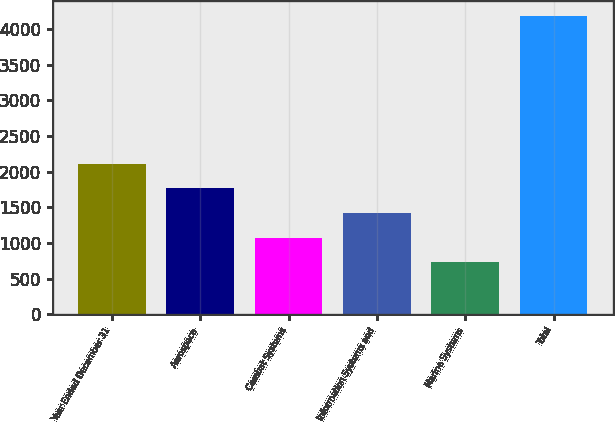Convert chart. <chart><loc_0><loc_0><loc_500><loc_500><bar_chart><fcel>Year Ended December 31<fcel>Aerospace<fcel>Combat Systems<fcel>Information Systems and<fcel>Marine Systems<fcel>Total<nl><fcel>2108<fcel>1763<fcel>1073<fcel>1418<fcel>728<fcel>4178<nl></chart> 